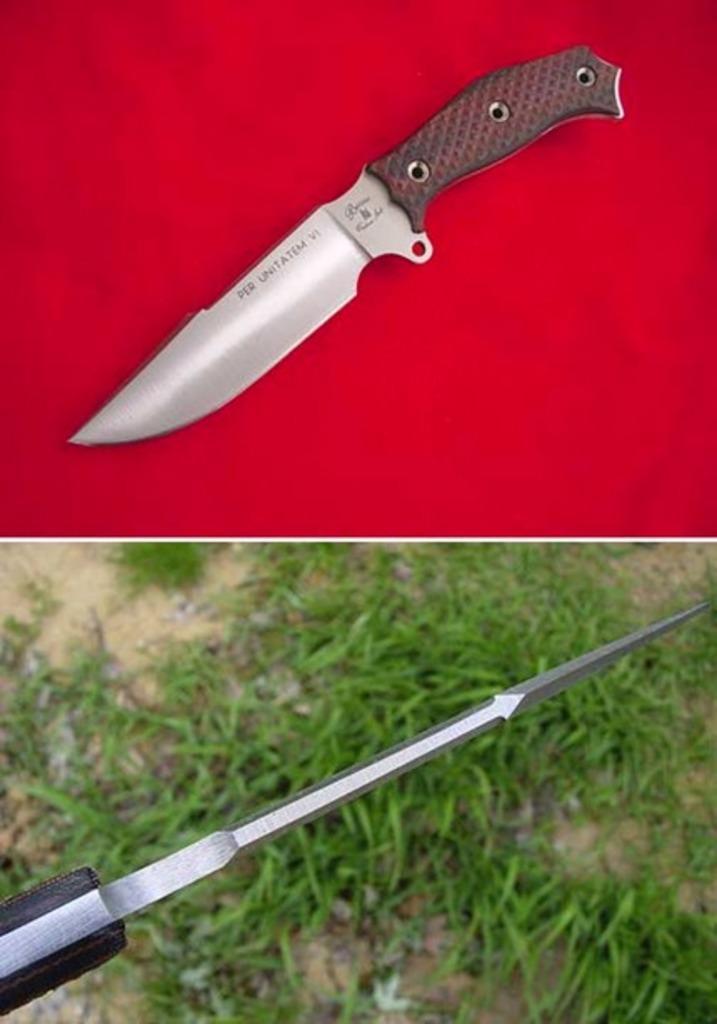How would you summarize this image in a sentence or two? In this image there is a collage of two images. In one image there is a knife and in another image there is a drill bit. 